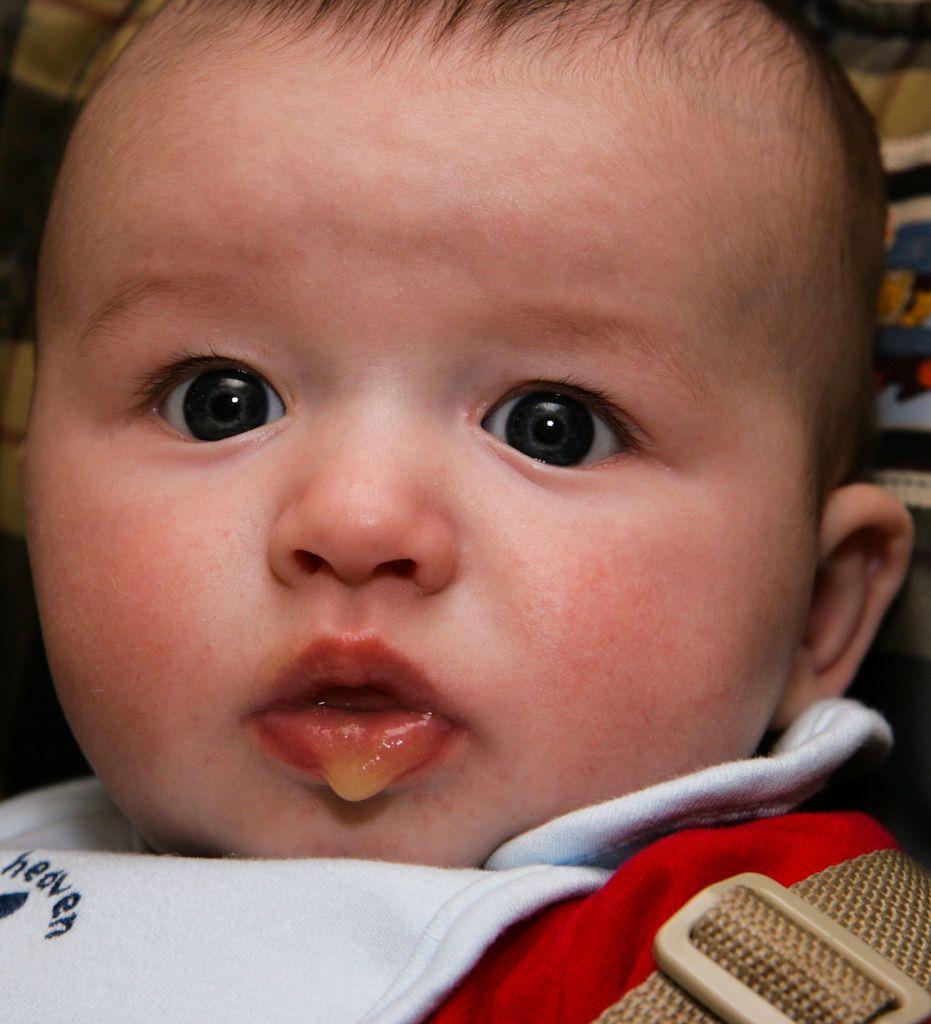How would you summarize this image in a sentence or two? In this image we can see a baby. 